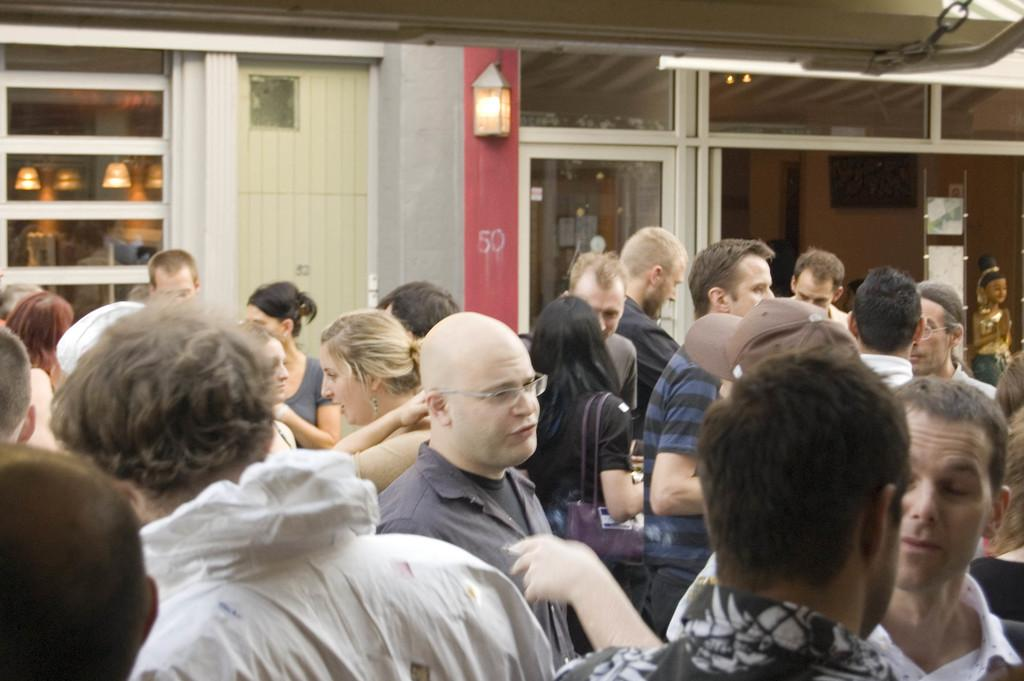How many people are in the image? There is a group of people in the image, but the exact number cannot be determined from the provided facts. What can be seen in the background of the image? There is a wall and lights in the background of the image, as well as other objects. Can you describe the wall in the background? The facts provided do not give enough information to describe the wall in the background. What type of lock is used to secure the thought in the image? There is no mention of a lock or a thought in the image, so this question cannot be answered. 